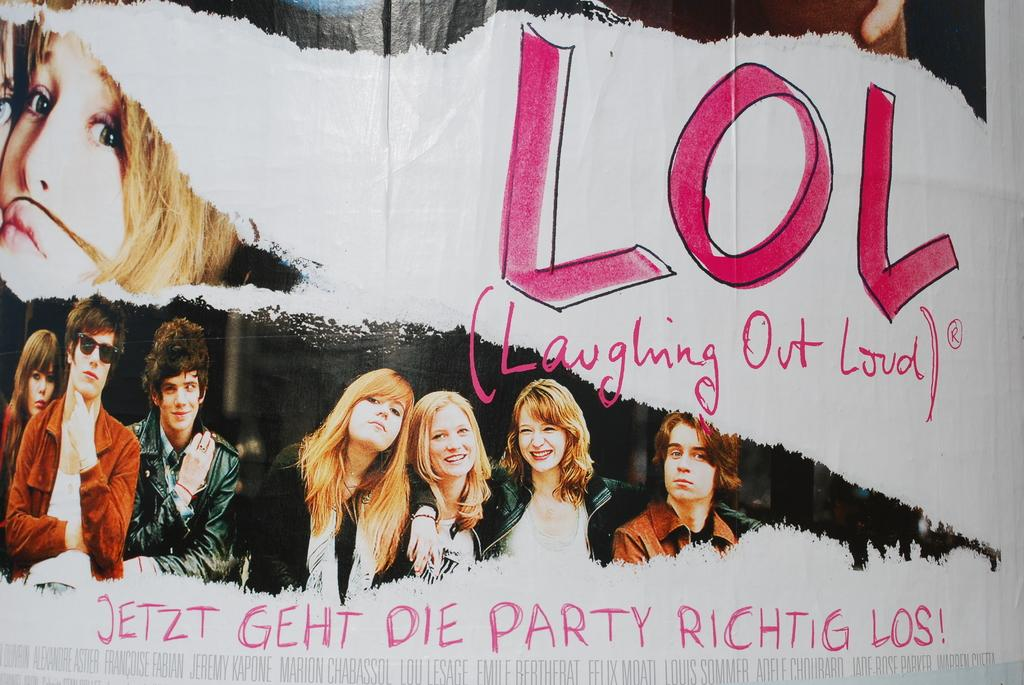What is the main object in the image? There is a banner in the image. What can be seen on the banner? There are pictures of people on the banner. Is there any text on the banner? Yes, there is text on the banner. What type of worm can be seen crawling on the banner in the image? There is no worm present on the banner in the image. 